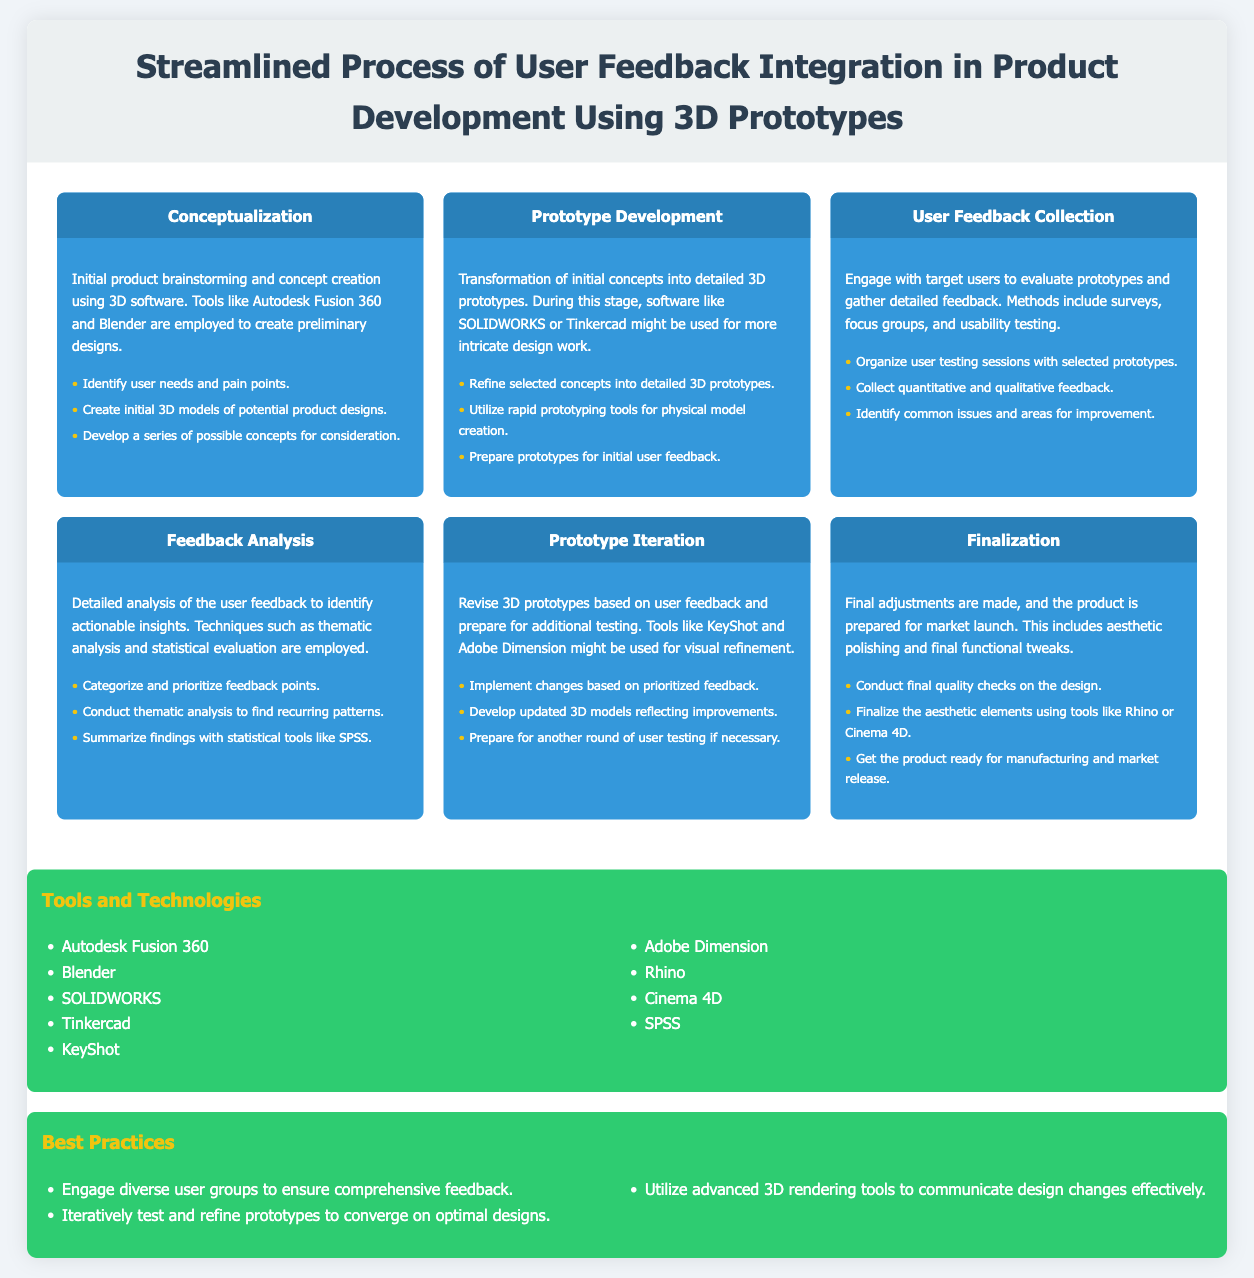what is the first stage in the process? The first stage in the process is identified as the "Conceptualization" stage.
Answer: Conceptualization which tools are mentioned for prototype development? The tools mentioned for prototype development include SOLIDWORKS and Tinkercad.
Answer: SOLIDWORKS, Tinkercad how many key tasks are listed under "Feedback Analysis"? There are three key tasks listed under the "Feedback Analysis" stage.
Answer: 3 what is a best practice mentioned in the document? A best practice mentioned is to engage diverse user groups to ensure comprehensive feedback.
Answer: Engage diverse user groups which stage involves user testing sessions? The stage involving user testing sessions is "User Feedback Collection."
Answer: User Feedback Collection what is the purpose of the 'Finalization' stage? The purpose of the 'Finalization' stage is to make final adjustments and prepare the product for market launch.
Answer: Prepare for market launch how many tools and technologies are listed in total? There are nine tools and technologies listed in the document.
Answer: 9 which software is suggested for aesthetic polishing? The software suggested for aesthetic polishing is Rhino or Cinema 4D.
Answer: Rhino, Cinema 4D what is one technique used in 'Feedback Analysis'? One technique used in 'Feedback Analysis' is thematic analysis.
Answer: Thematic analysis 